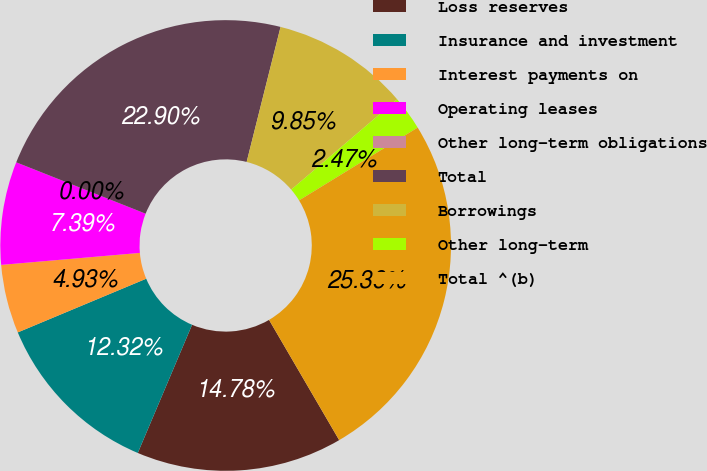Convert chart. <chart><loc_0><loc_0><loc_500><loc_500><pie_chart><fcel>Loss reserves<fcel>Insurance and investment<fcel>Interest payments on<fcel>Operating leases<fcel>Other long-term obligations<fcel>Total<fcel>Borrowings<fcel>Other long-term<fcel>Total ^(b)<nl><fcel>14.78%<fcel>12.32%<fcel>4.93%<fcel>7.39%<fcel>0.0%<fcel>22.9%<fcel>9.85%<fcel>2.47%<fcel>25.36%<nl></chart> 